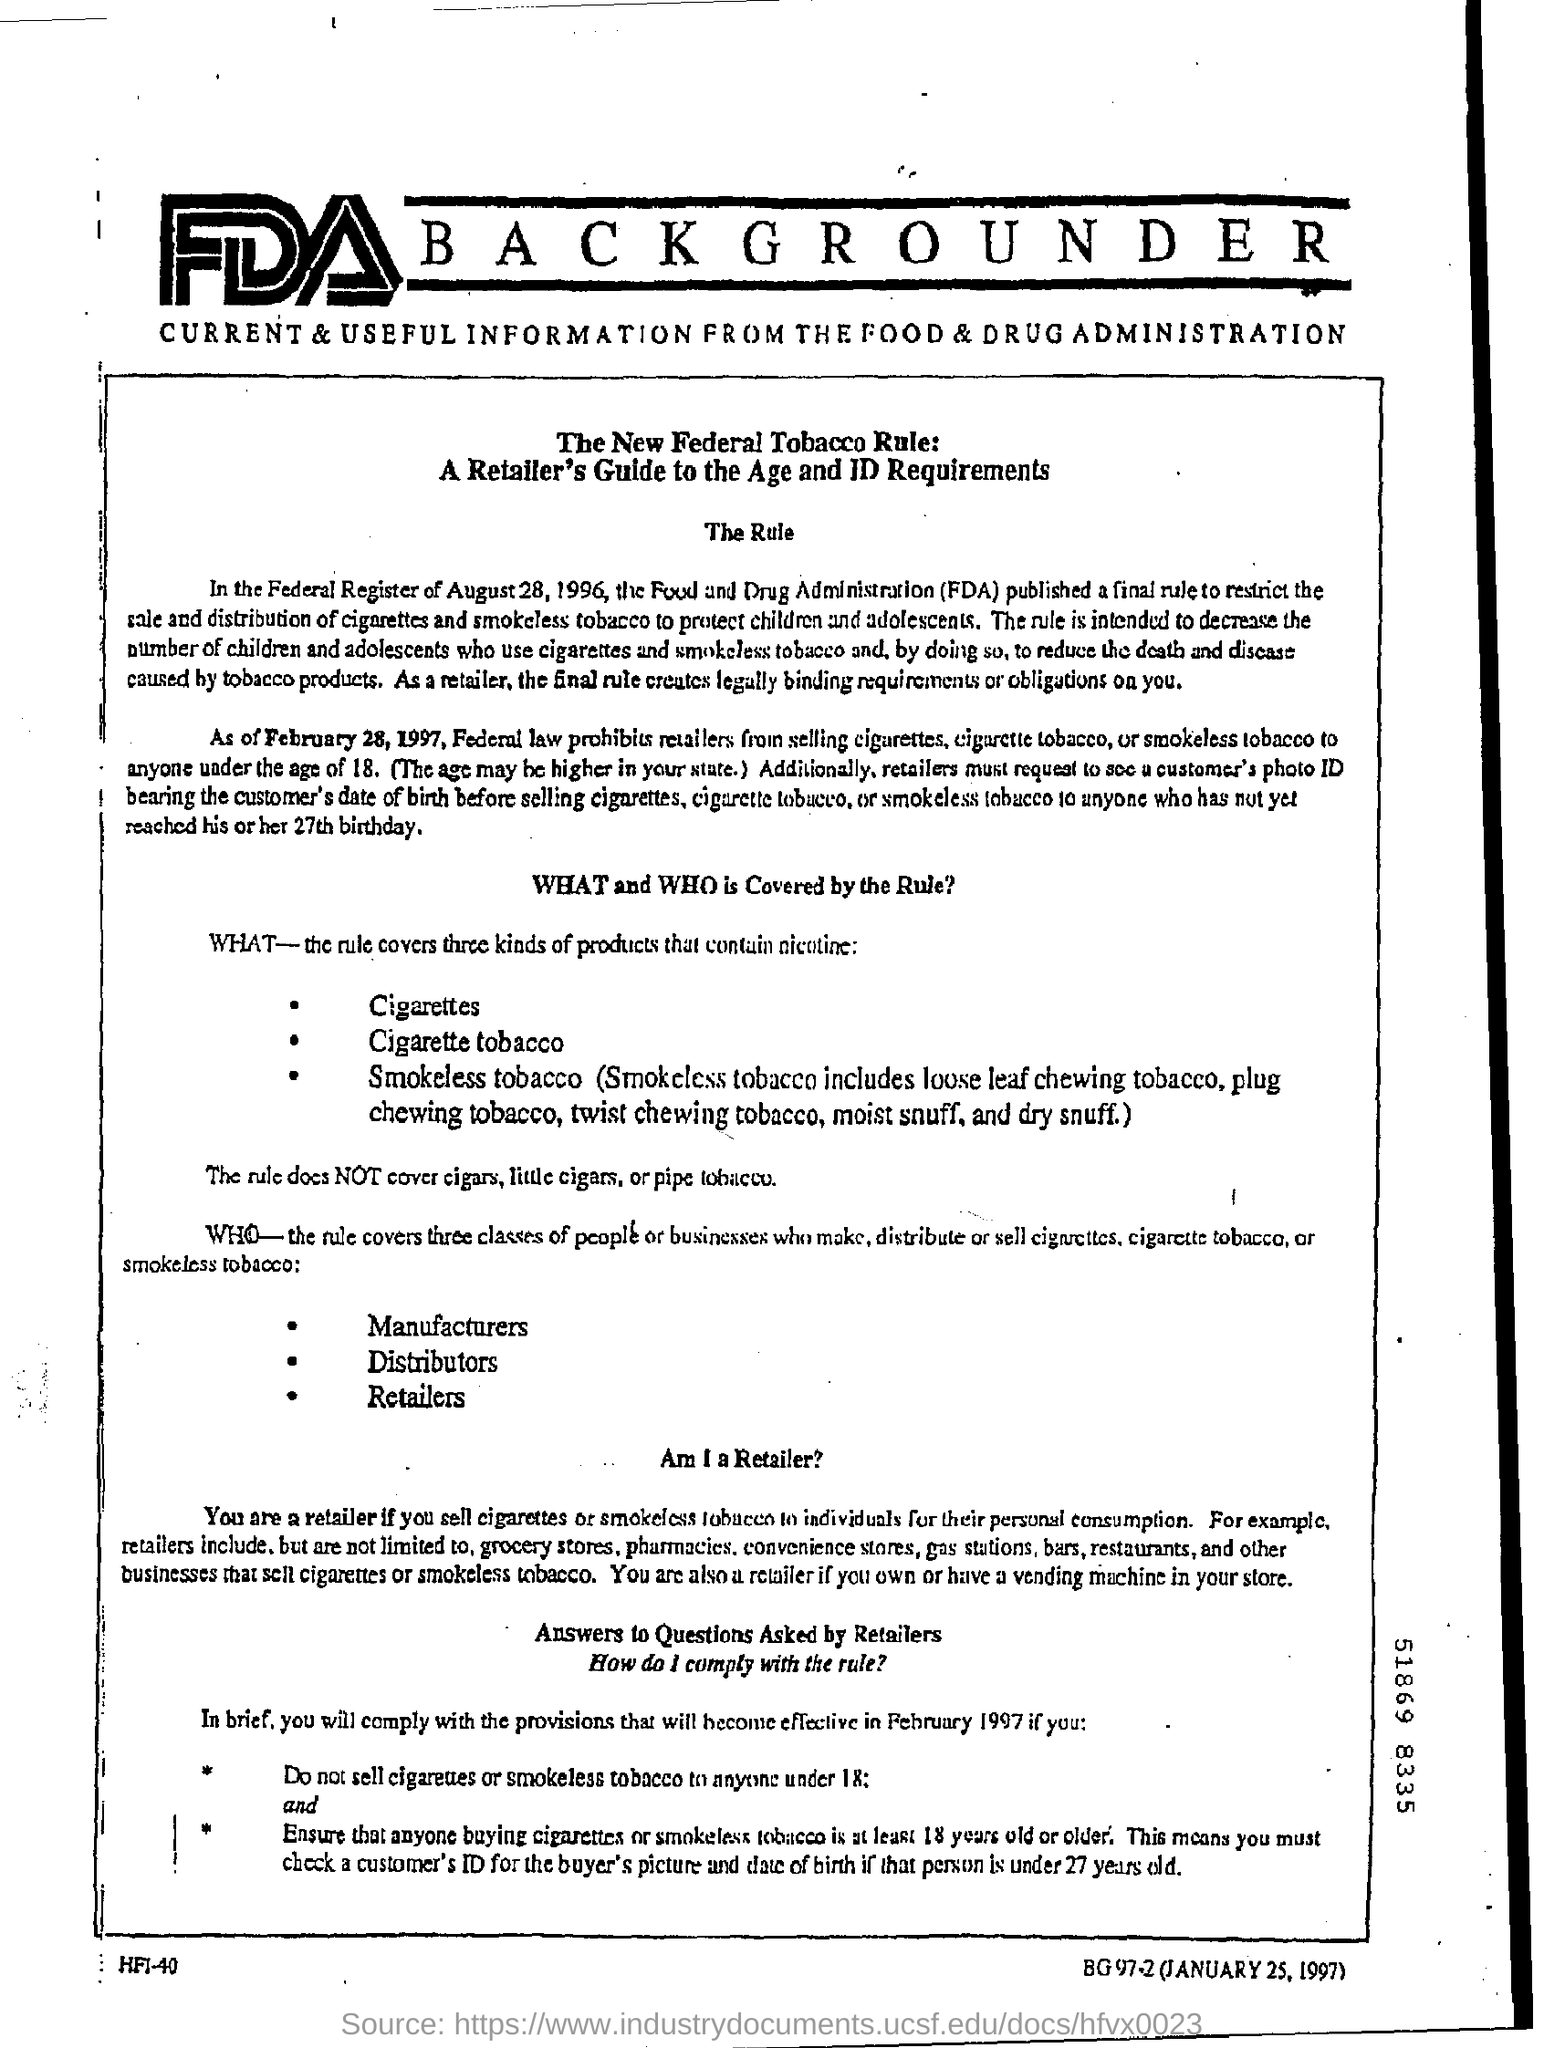How many kinds of products does rule covers?
Offer a terse response. Three. How many kinds of products which containe nicotine are covered by this rule?
Offer a very short reply. Three. Who is a retailer based on this document?
Provide a short and direct response. Sell cigarettes or smokeless tobacco to individuals for their personal consumption. Less than which age people cigarettes shouldn't be sold?
Your answer should be compact. 18. 